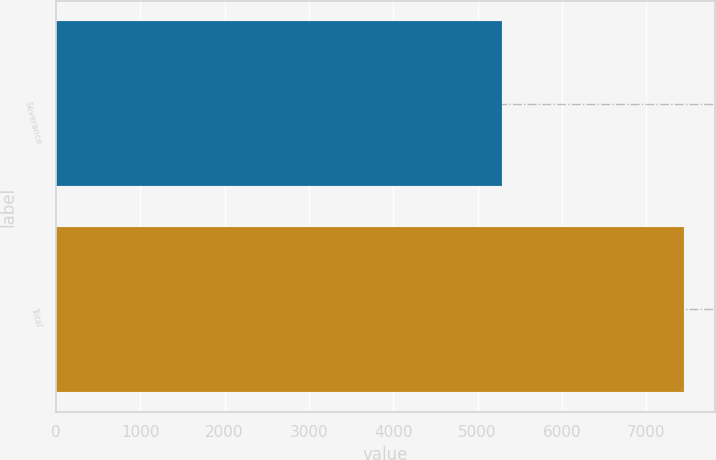Convert chart to OTSL. <chart><loc_0><loc_0><loc_500><loc_500><bar_chart><fcel>Severance<fcel>Total<nl><fcel>5296<fcel>7445<nl></chart> 